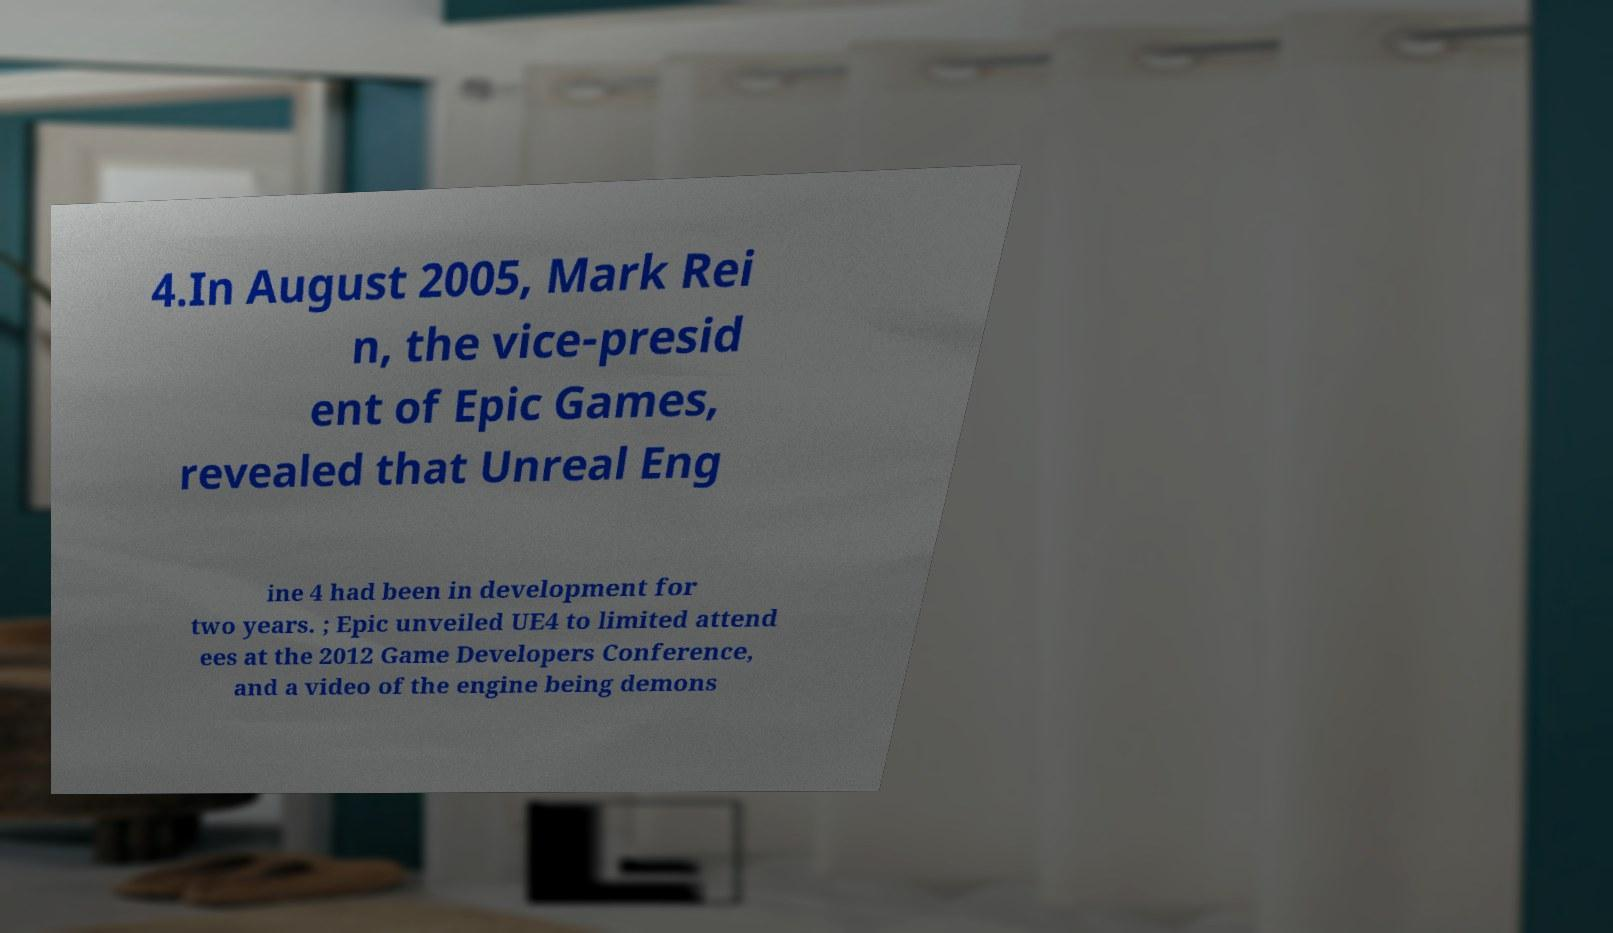What messages or text are displayed in this image? I need them in a readable, typed format. 4.In August 2005, Mark Rei n, the vice-presid ent of Epic Games, revealed that Unreal Eng ine 4 had been in development for two years. ; Epic unveiled UE4 to limited attend ees at the 2012 Game Developers Conference, and a video of the engine being demons 